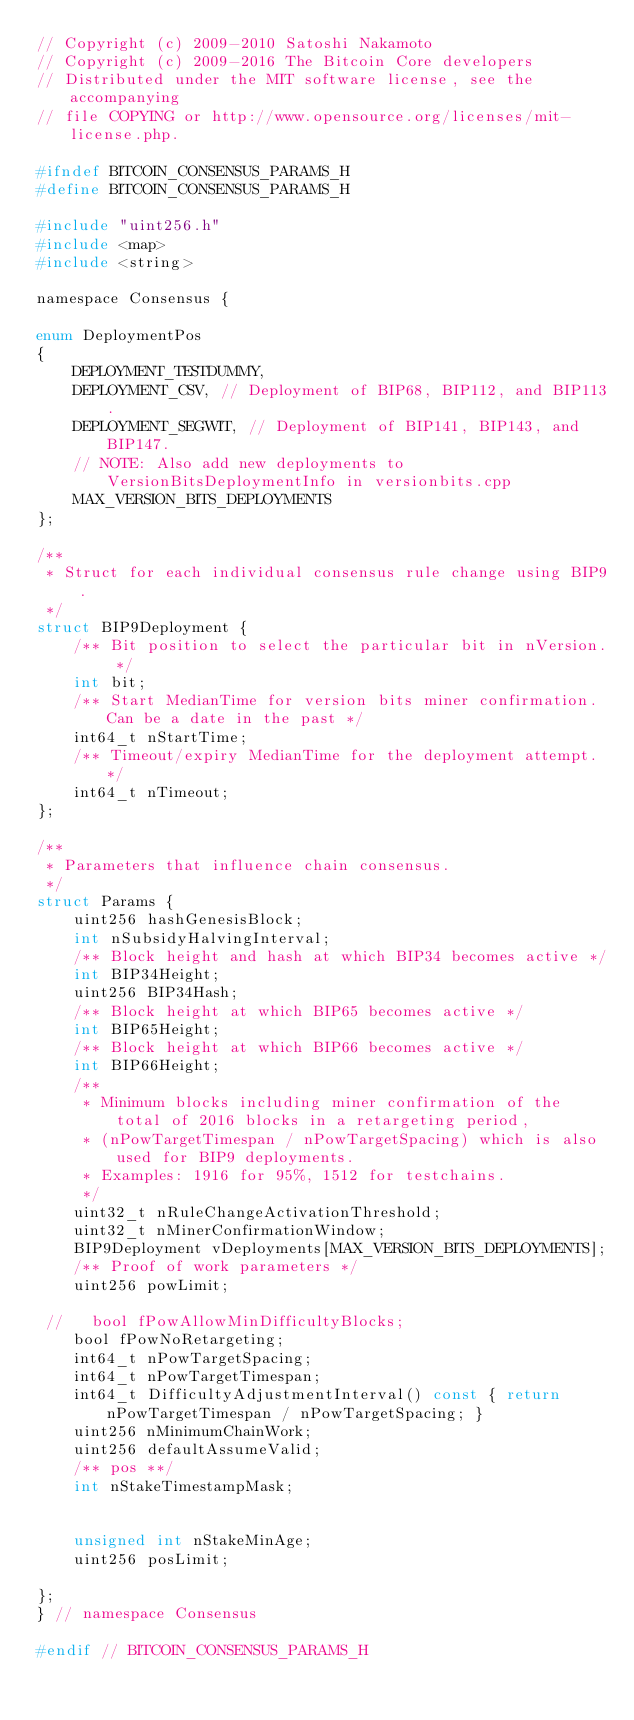<code> <loc_0><loc_0><loc_500><loc_500><_C_>// Copyright (c) 2009-2010 Satoshi Nakamoto
// Copyright (c) 2009-2016 The Bitcoin Core developers
// Distributed under the MIT software license, see the accompanying
// file COPYING or http://www.opensource.org/licenses/mit-license.php.

#ifndef BITCOIN_CONSENSUS_PARAMS_H
#define BITCOIN_CONSENSUS_PARAMS_H

#include "uint256.h"
#include <map>
#include <string>

namespace Consensus {

enum DeploymentPos
{
    DEPLOYMENT_TESTDUMMY,
    DEPLOYMENT_CSV, // Deployment of BIP68, BIP112, and BIP113.
    DEPLOYMENT_SEGWIT, // Deployment of BIP141, BIP143, and BIP147.
    // NOTE: Also add new deployments to VersionBitsDeploymentInfo in versionbits.cpp
    MAX_VERSION_BITS_DEPLOYMENTS
};

/**
 * Struct for each individual consensus rule change using BIP9.
 */
struct BIP9Deployment {
    /** Bit position to select the particular bit in nVersion. */
    int bit;
    /** Start MedianTime for version bits miner confirmation. Can be a date in the past */
    int64_t nStartTime;
    /** Timeout/expiry MedianTime for the deployment attempt. */
    int64_t nTimeout;
};

/**
 * Parameters that influence chain consensus.
 */
struct Params {
    uint256 hashGenesisBlock;
    int nSubsidyHalvingInterval;
    /** Block height and hash at which BIP34 becomes active */
    int BIP34Height;
    uint256 BIP34Hash;
    /** Block height at which BIP65 becomes active */
    int BIP65Height;
    /** Block height at which BIP66 becomes active */
    int BIP66Height;
    /**
     * Minimum blocks including miner confirmation of the total of 2016 blocks in a retargeting period,
     * (nPowTargetTimespan / nPowTargetSpacing) which is also used for BIP9 deployments.
     * Examples: 1916 for 95%, 1512 for testchains.
     */
    uint32_t nRuleChangeActivationThreshold;
    uint32_t nMinerConfirmationWindow;
    BIP9Deployment vDeployments[MAX_VERSION_BITS_DEPLOYMENTS];
    /** Proof of work parameters */
    uint256 powLimit;
    
 //   bool fPowAllowMinDifficultyBlocks;
    bool fPowNoRetargeting;
    int64_t nPowTargetSpacing;
    int64_t nPowTargetTimespan;
    int64_t DifficultyAdjustmentInterval() const { return nPowTargetTimespan / nPowTargetSpacing; }
    uint256 nMinimumChainWork;
    uint256 defaultAssumeValid;
    /** pos **/
    int nStakeTimestampMask;
    
    
    unsigned int nStakeMinAge;
    uint256 posLimit;
    
};
} // namespace Consensus

#endif // BITCOIN_CONSENSUS_PARAMS_H
</code> 